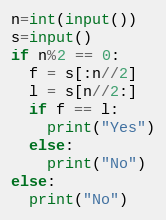Convert code to text. <code><loc_0><loc_0><loc_500><loc_500><_Python_>n=int(input())
s=input()
if n%2 == 0:
  f = s[:n//2]
  l = s[n//2:]
  if f == l:
    print("Yes")
  else:
    print("No")
else:
  print("No")</code> 